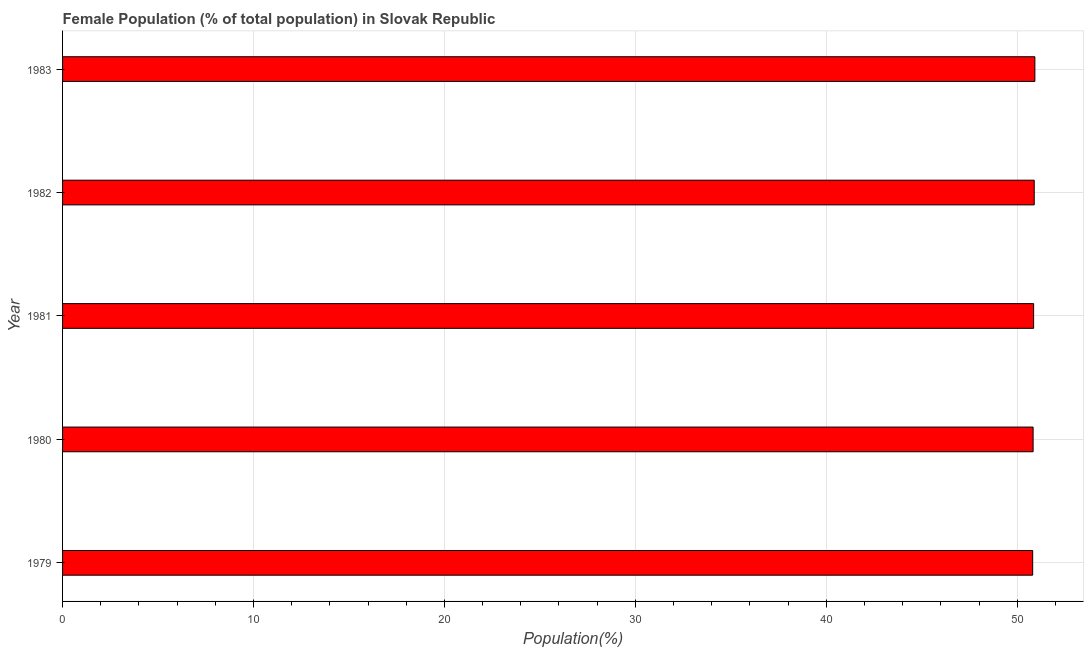Does the graph contain grids?
Your answer should be compact. Yes. What is the title of the graph?
Offer a terse response. Female Population (% of total population) in Slovak Republic. What is the label or title of the X-axis?
Offer a terse response. Population(%). What is the label or title of the Y-axis?
Give a very brief answer. Year. What is the female population in 1981?
Your answer should be very brief. 50.86. Across all years, what is the maximum female population?
Your answer should be very brief. 50.92. Across all years, what is the minimum female population?
Provide a short and direct response. 50.81. In which year was the female population minimum?
Ensure brevity in your answer.  1979. What is the sum of the female population?
Offer a terse response. 254.31. What is the average female population per year?
Provide a succinct answer. 50.86. What is the median female population?
Offer a terse response. 50.86. In how many years, is the female population greater than 30 %?
Offer a terse response. 5. Is the female population in 1979 less than that in 1981?
Provide a short and direct response. Yes. Is the difference between the female population in 1980 and 1983 greater than the difference between any two years?
Keep it short and to the point. No. What is the difference between the highest and the second highest female population?
Keep it short and to the point. 0.03. Is the sum of the female population in 1980 and 1981 greater than the maximum female population across all years?
Your answer should be compact. Yes. What is the difference between the highest and the lowest female population?
Ensure brevity in your answer.  0.12. In how many years, is the female population greater than the average female population taken over all years?
Offer a terse response. 2. How many bars are there?
Provide a short and direct response. 5. How many years are there in the graph?
Make the answer very short. 5. Are the values on the major ticks of X-axis written in scientific E-notation?
Your response must be concise. No. What is the Population(%) of 1979?
Provide a succinct answer. 50.81. What is the Population(%) in 1980?
Make the answer very short. 50.83. What is the Population(%) of 1981?
Ensure brevity in your answer.  50.86. What is the Population(%) of 1982?
Offer a very short reply. 50.89. What is the Population(%) of 1983?
Give a very brief answer. 50.92. What is the difference between the Population(%) in 1979 and 1980?
Your response must be concise. -0.02. What is the difference between the Population(%) in 1979 and 1981?
Give a very brief answer. -0.05. What is the difference between the Population(%) in 1979 and 1982?
Give a very brief answer. -0.08. What is the difference between the Population(%) in 1979 and 1983?
Your response must be concise. -0.12. What is the difference between the Population(%) in 1980 and 1981?
Provide a succinct answer. -0.03. What is the difference between the Population(%) in 1980 and 1982?
Your response must be concise. -0.06. What is the difference between the Population(%) in 1980 and 1983?
Make the answer very short. -0.09. What is the difference between the Population(%) in 1981 and 1982?
Provide a succinct answer. -0.03. What is the difference between the Population(%) in 1981 and 1983?
Provide a succinct answer. -0.07. What is the difference between the Population(%) in 1982 and 1983?
Provide a short and direct response. -0.03. What is the ratio of the Population(%) in 1979 to that in 1982?
Give a very brief answer. 1. What is the ratio of the Population(%) in 1980 to that in 1981?
Your answer should be compact. 1. What is the ratio of the Population(%) in 1980 to that in 1983?
Offer a terse response. 1. What is the ratio of the Population(%) in 1981 to that in 1982?
Give a very brief answer. 1. What is the ratio of the Population(%) in 1981 to that in 1983?
Give a very brief answer. 1. 